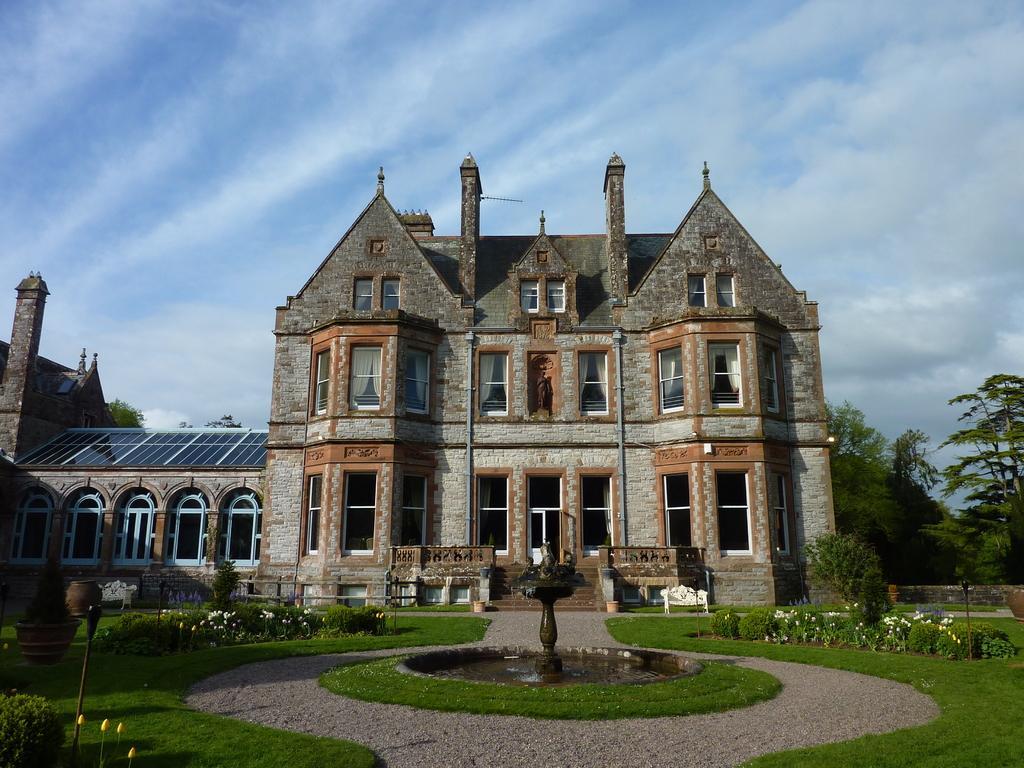Please provide a concise description of this image. There are flower plants, grassland and a fountain in the foreground area of the image, there are houses, benches, trees and the sky in the background. 